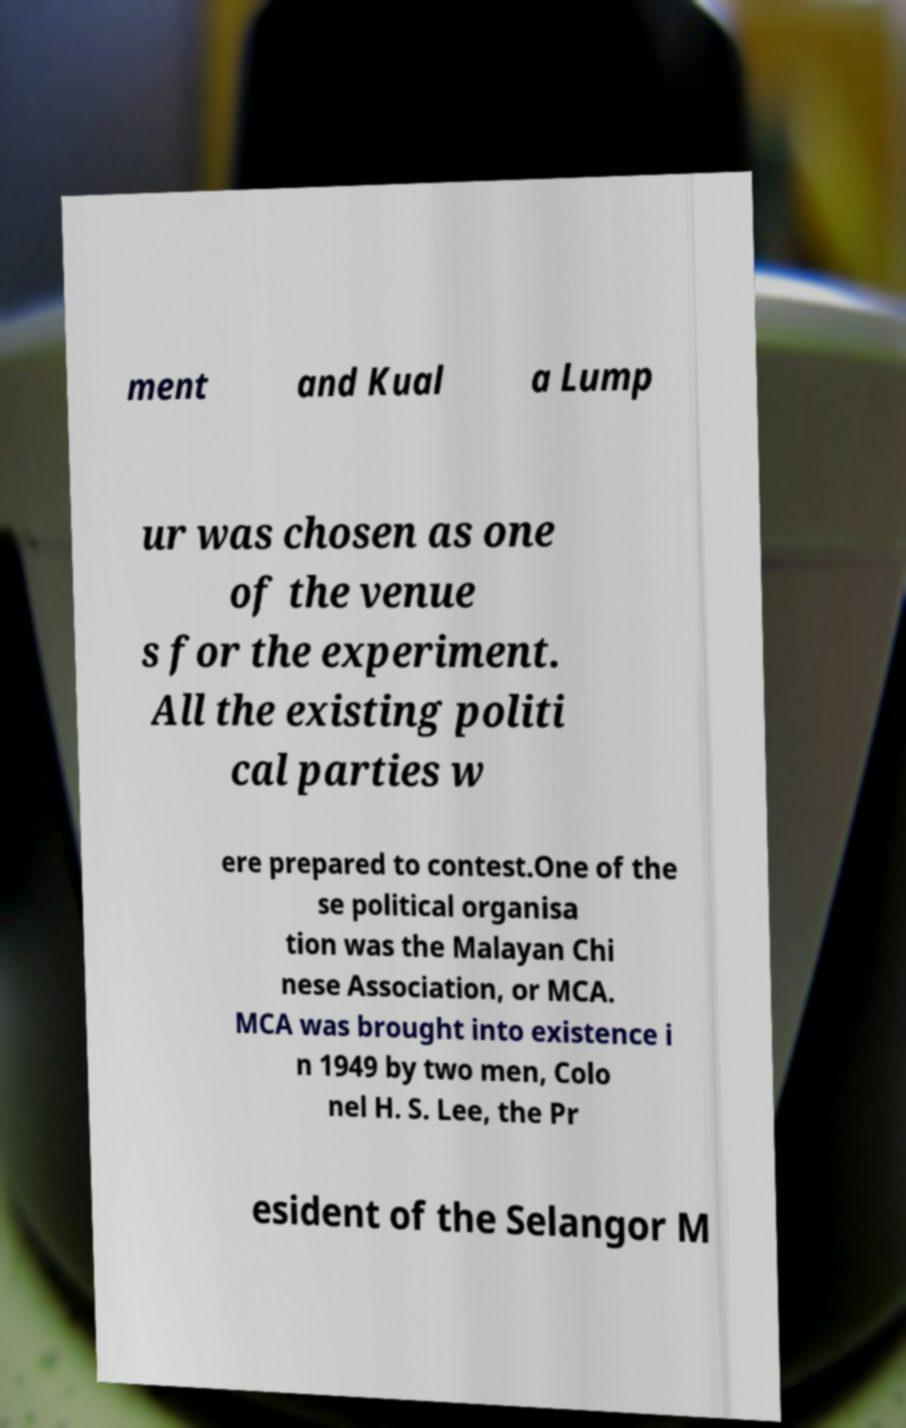There's text embedded in this image that I need extracted. Can you transcribe it verbatim? ment and Kual a Lump ur was chosen as one of the venue s for the experiment. All the existing politi cal parties w ere prepared to contest.One of the se political organisa tion was the Malayan Chi nese Association, or MCA. MCA was brought into existence i n 1949 by two men, Colo nel H. S. Lee, the Pr esident of the Selangor M 